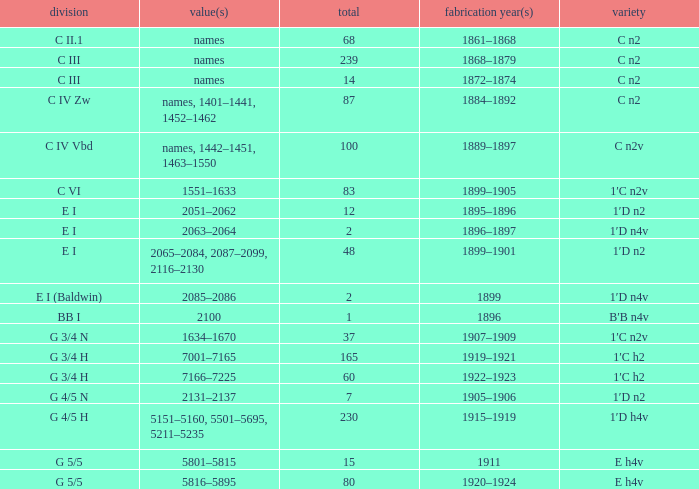Which Quantity has a Type of e h4v, and a Year(s) of Manufacture of 1920–1924? 80.0. 